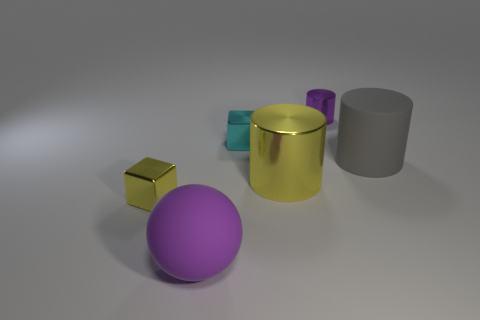There is a big thing that is left of the large gray thing and right of the cyan object; what is its shape?
Your answer should be compact. Cylinder. Is the color of the big rubber cylinder the same as the metal cube that is in front of the big metal object?
Provide a short and direct response. No. There is a yellow metallic object to the left of the yellow shiny cylinder; is it the same size as the big yellow shiny cylinder?
Your response must be concise. No. What is the material of the small object that is the same shape as the large metal thing?
Offer a very short reply. Metal. Do the small purple shiny thing and the large gray thing have the same shape?
Your answer should be compact. Yes. There is a small purple metallic thing that is right of the cyan block; how many objects are on the left side of it?
Ensure brevity in your answer.  4. There is a large purple thing that is the same material as the large gray cylinder; what shape is it?
Make the answer very short. Sphere. What number of cyan things are metal things or small objects?
Your answer should be compact. 1. There is a shiny cube on the right side of the metal block that is in front of the large matte cylinder; is there a metal thing right of it?
Give a very brief answer. Yes. Are there fewer purple shiny things than big cylinders?
Offer a terse response. Yes. 